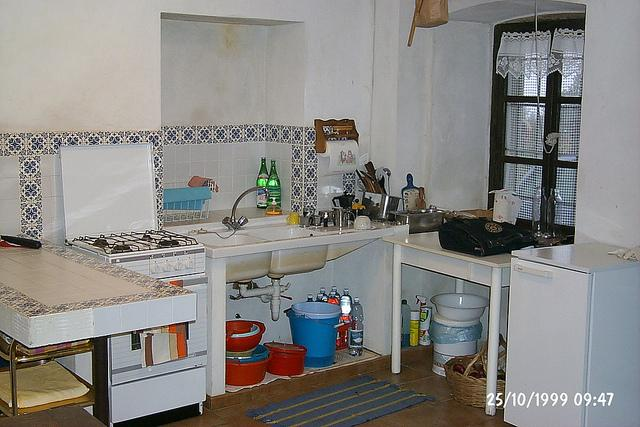What is the large circular blue object under the sink?

Choices:
A) hose
B) bucket
C) ball
D) mat bucket 